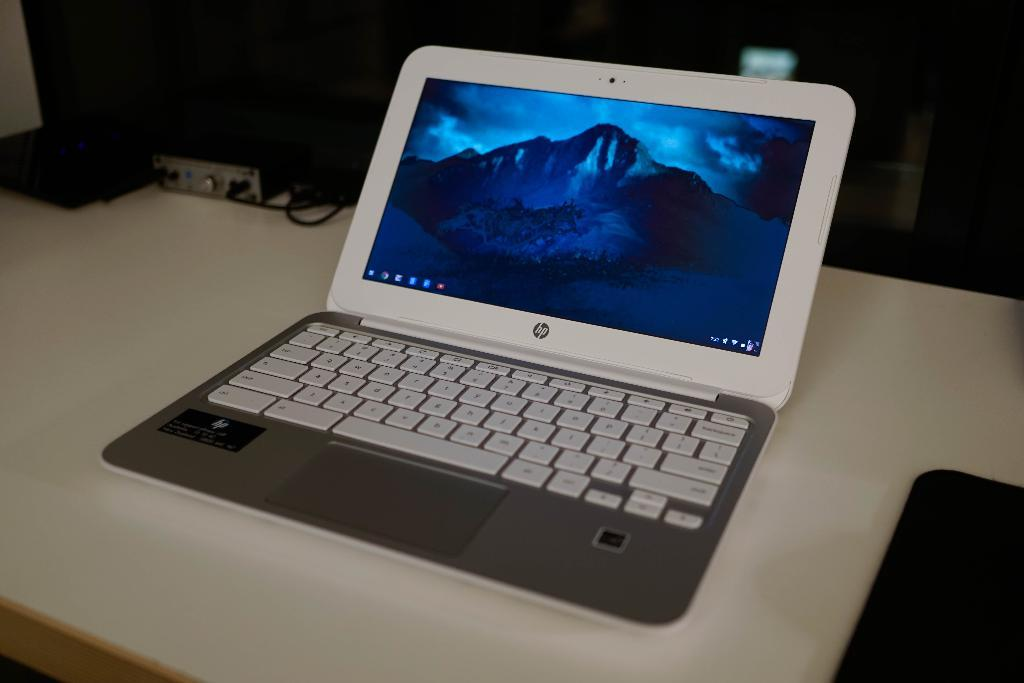Provide a one-sentence caption for the provided image. An hp brand laptop has a mountain as the background screen image. 